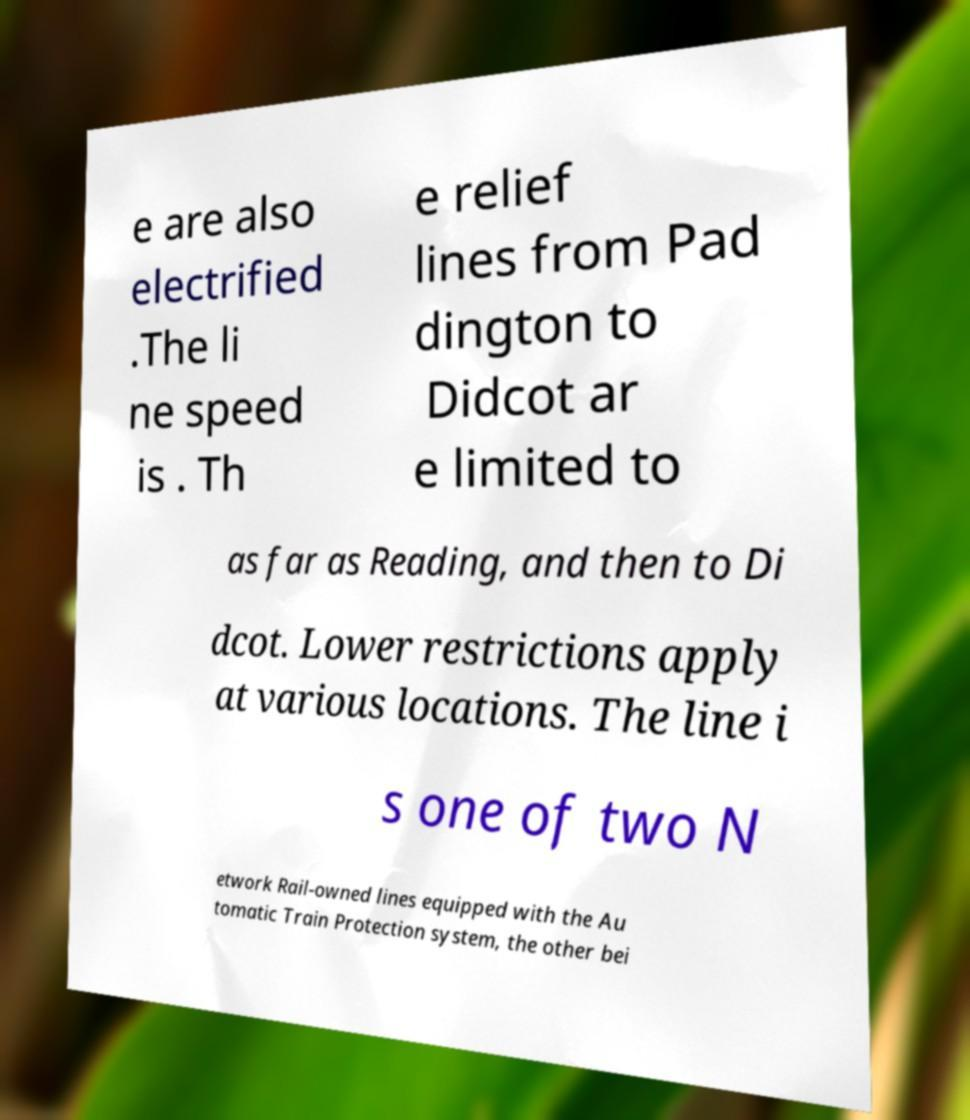I need the written content from this picture converted into text. Can you do that? e are also electrified .The li ne speed is . Th e relief lines from Pad dington to Didcot ar e limited to as far as Reading, and then to Di dcot. Lower restrictions apply at various locations. The line i s one of two N etwork Rail-owned lines equipped with the Au tomatic Train Protection system, the other bei 